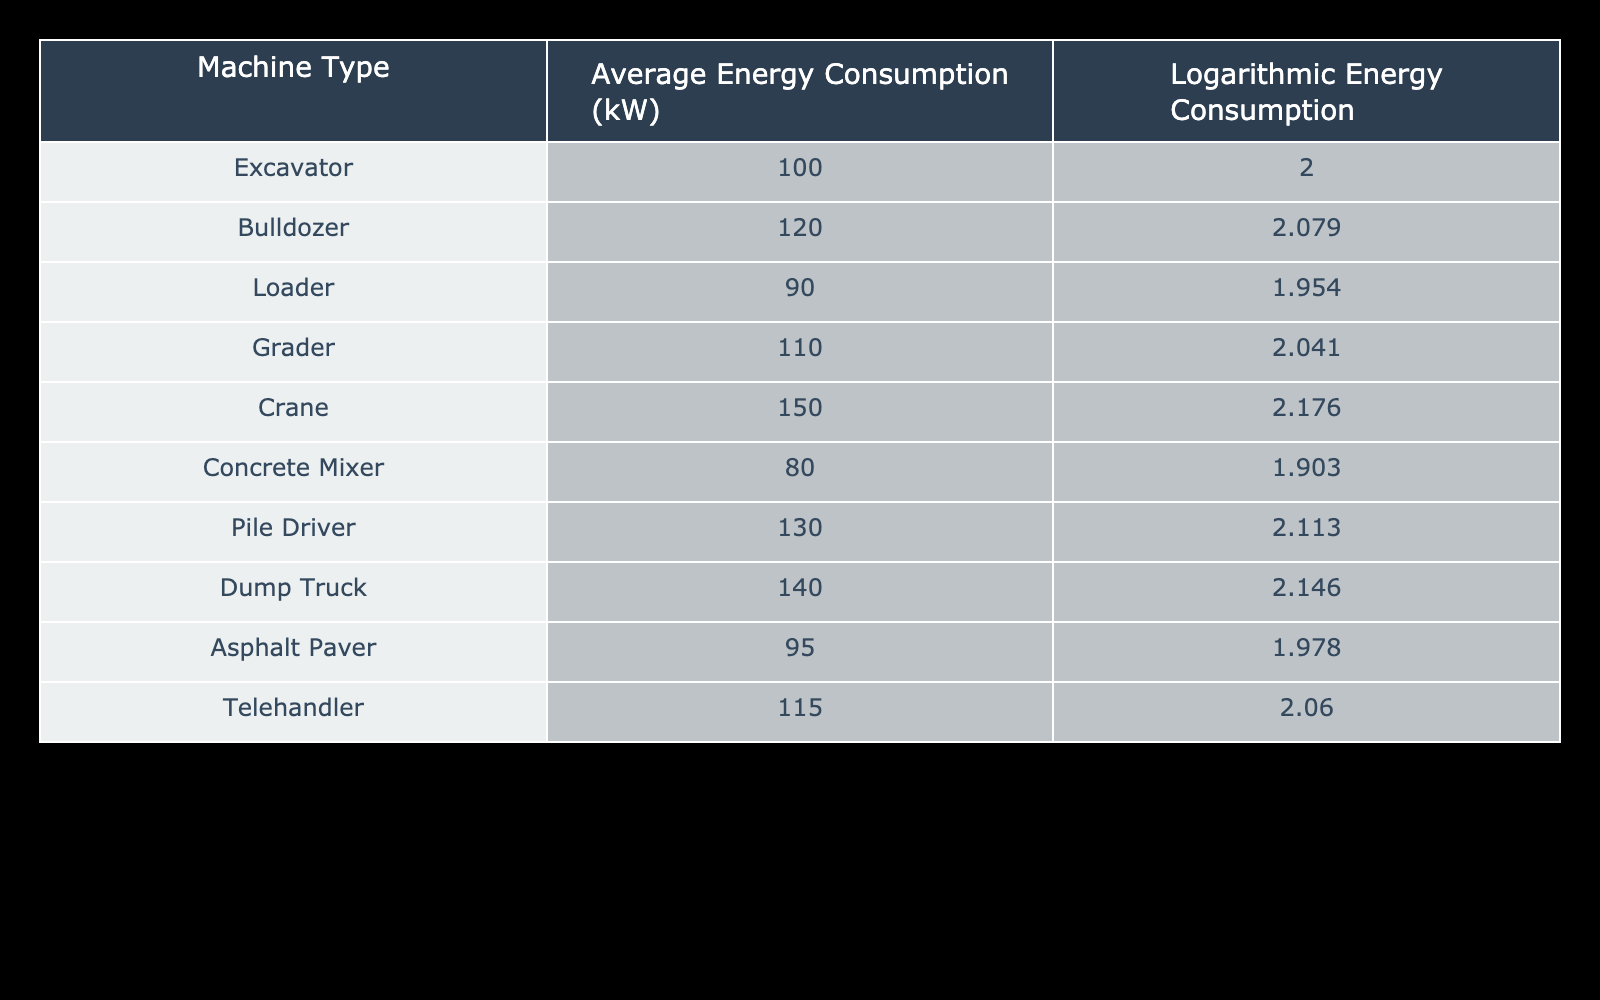What is the average energy consumption of the bulldozer? The average energy consumption of the bulldozer is listed directly in the table as 120 kW.
Answer: 120 kW Which machine has the highest energy consumption? By looking at the average energy consumption values in the table, the crane has the highest value at 150 kW.
Answer: Crane Is the energy consumption of the concrete mixer greater than 100 kW? The table shows that the average energy consumption of the concrete mixer is 80 kW, which is less than 100 kW. Therefore, the statement is false.
Answer: No What is the logarithmic energy consumption of the pile driver? The logarithmic energy consumption for the pile driver is provided in the table as 2.113.
Answer: 2.113 What is the difference in average energy consumption between the dump truck and the loader? The average energy consumption of the dump truck is 140 kW and the loader is 90 kW. The difference is calculated as 140 - 90 = 50 kW.
Answer: 50 kW What is the total average energy consumption of all machines listed? To find the total average energy consumption, sum the energy consumption values: 100 + 120 + 90 + 110 + 150 + 80 + 130 + 140 + 95 + 115 = 1,100 kW. The total for all machines is 1,100 kW.
Answer: 1100 kW Are there more machines with energy consumption below 100 kW or above 100 kW? By reviewing the table, the machines below 100 kW are the loader (90), concrete mixer (80), and asphalt paver (95) totaling 3 machines. The machines above 100 kW are the excavator (100), bulldozer (120), grader (110), crane (150), pile driver (130), dump truck (140), and telehandler (115) totaling 7 machines. Therefore, there are more machines above 100 kW.
Answer: Yes What is the average logarithmic energy consumption of the loader and the concrete mixer? The logarithmic energy consumption for the loader is 1.954 and for the concrete mixer is 1.903. To find the average, sum these values and divide by 2: (1.954 + 1.903) / 2 = 1.9285.
Answer: 1.9285 Which machine type has the smallest logarithmic energy consumption? The concrete mixer has the smallest logarithmic energy consumption at 1.903, as shown in the table.
Answer: Concrete Mixer 